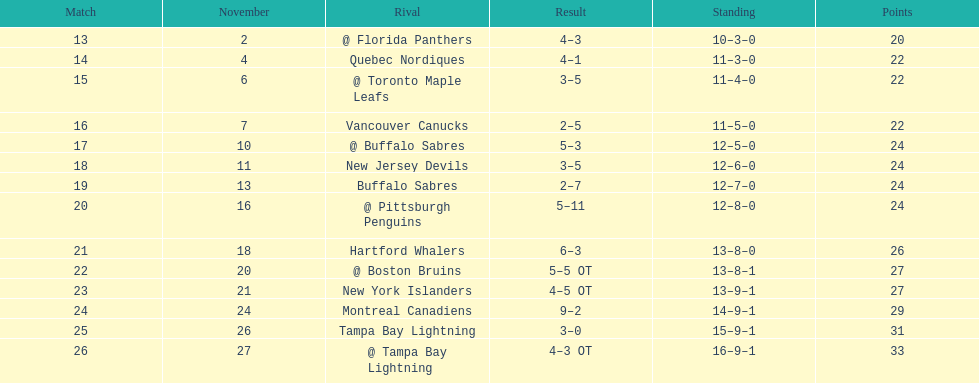Who did the philadelphia flyers play in game 17? @ Buffalo Sabres. What was the score of the november 10th game against the buffalo sabres? 5–3. Which team in the atlantic division had less points than the philadelphia flyers? Tampa Bay Lightning. 